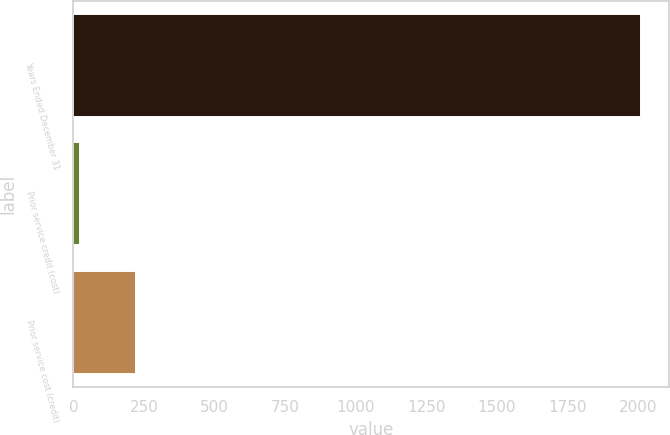Convert chart. <chart><loc_0><loc_0><loc_500><loc_500><bar_chart><fcel>Years Ended December 31<fcel>Prior service credit (cost)<fcel>Prior service cost (credit)<nl><fcel>2009<fcel>24<fcel>222.5<nl></chart> 